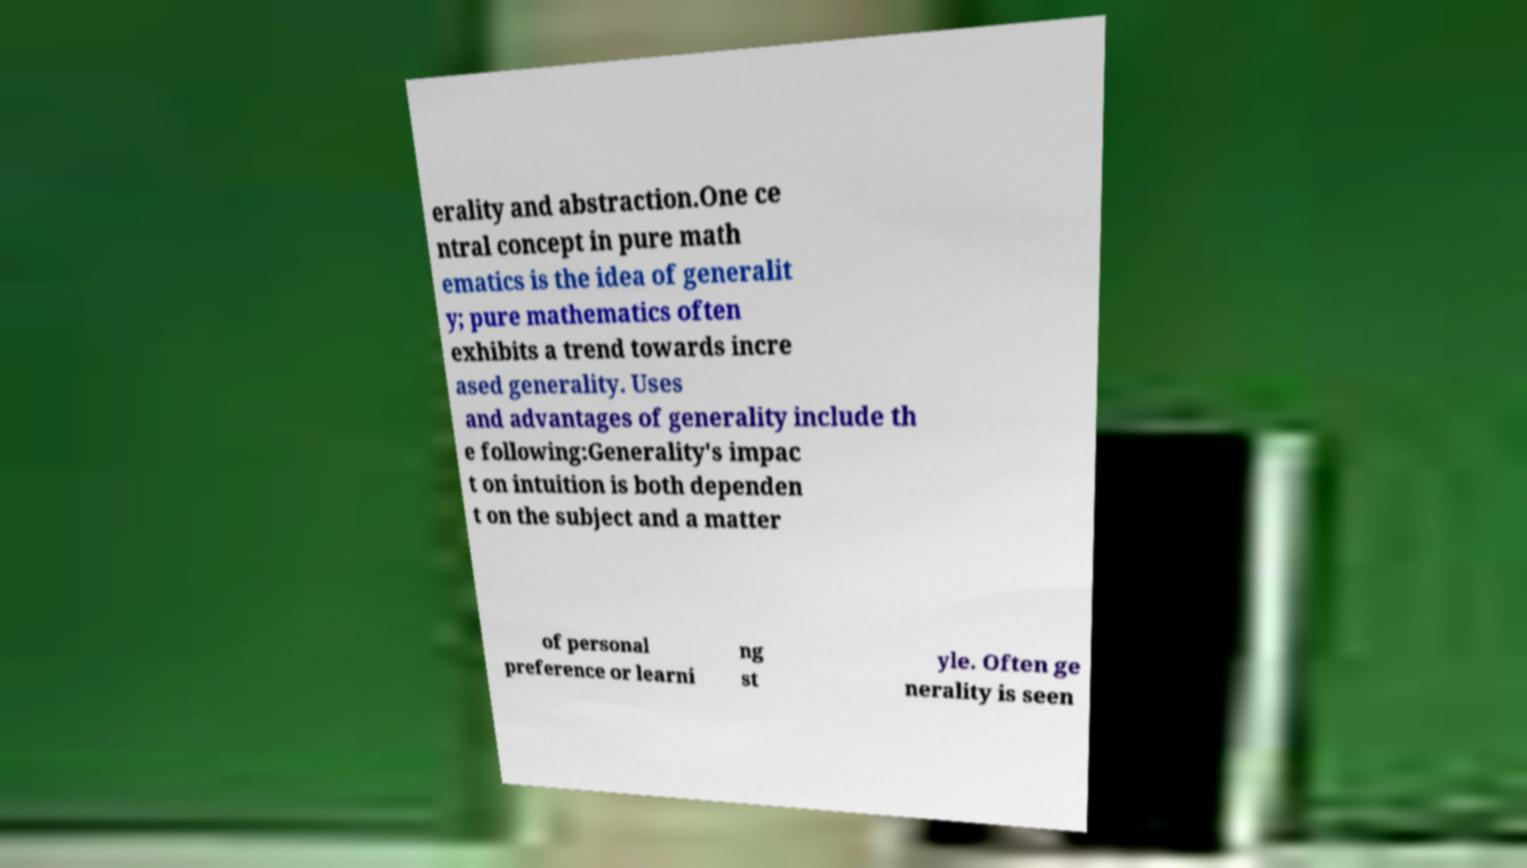Can you accurately transcribe the text from the provided image for me? erality and abstraction.One ce ntral concept in pure math ematics is the idea of generalit y; pure mathematics often exhibits a trend towards incre ased generality. Uses and advantages of generality include th e following:Generality's impac t on intuition is both dependen t on the subject and a matter of personal preference or learni ng st yle. Often ge nerality is seen 